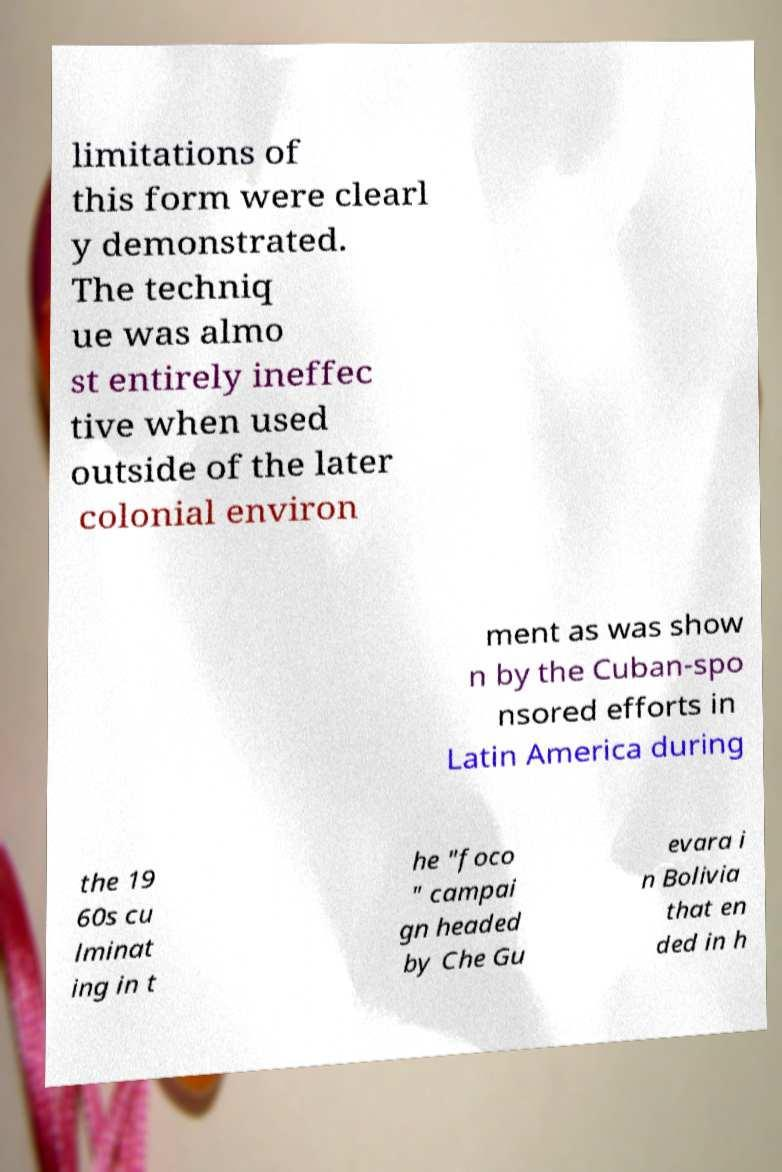Can you accurately transcribe the text from the provided image for me? limitations of this form were clearl y demonstrated. The techniq ue was almo st entirely ineffec tive when used outside of the later colonial environ ment as was show n by the Cuban-spo nsored efforts in Latin America during the 19 60s cu lminat ing in t he "foco " campai gn headed by Che Gu evara i n Bolivia that en ded in h 